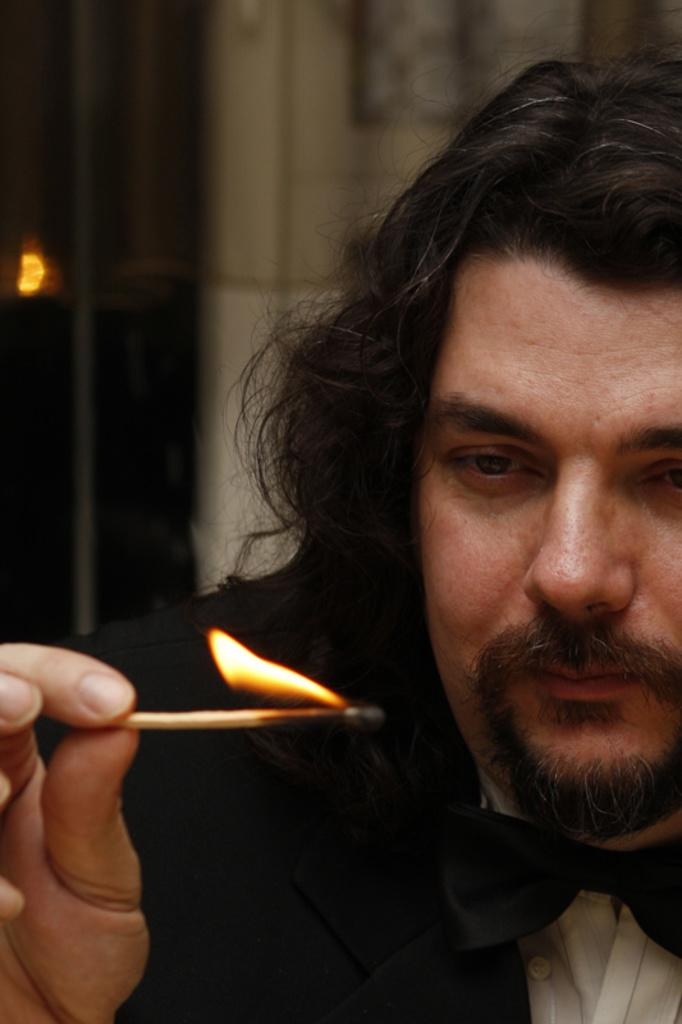Who is the main subject in the image? There is a man in the center of the image. What is the man holding in the image? The man is holding a matchstick with fire. What can be seen in the background of the image? There is light, grills, a pillar, a wall, and photo frames in the background of the image. How many children are present in the image? There are no children present in the image; it features a man holding a matchstick with fire and various background elements. What type of societal development is depicted in the image? The image does not depict any specific societal development; it focuses on a man holding a matchstick with fire and the background elements. 